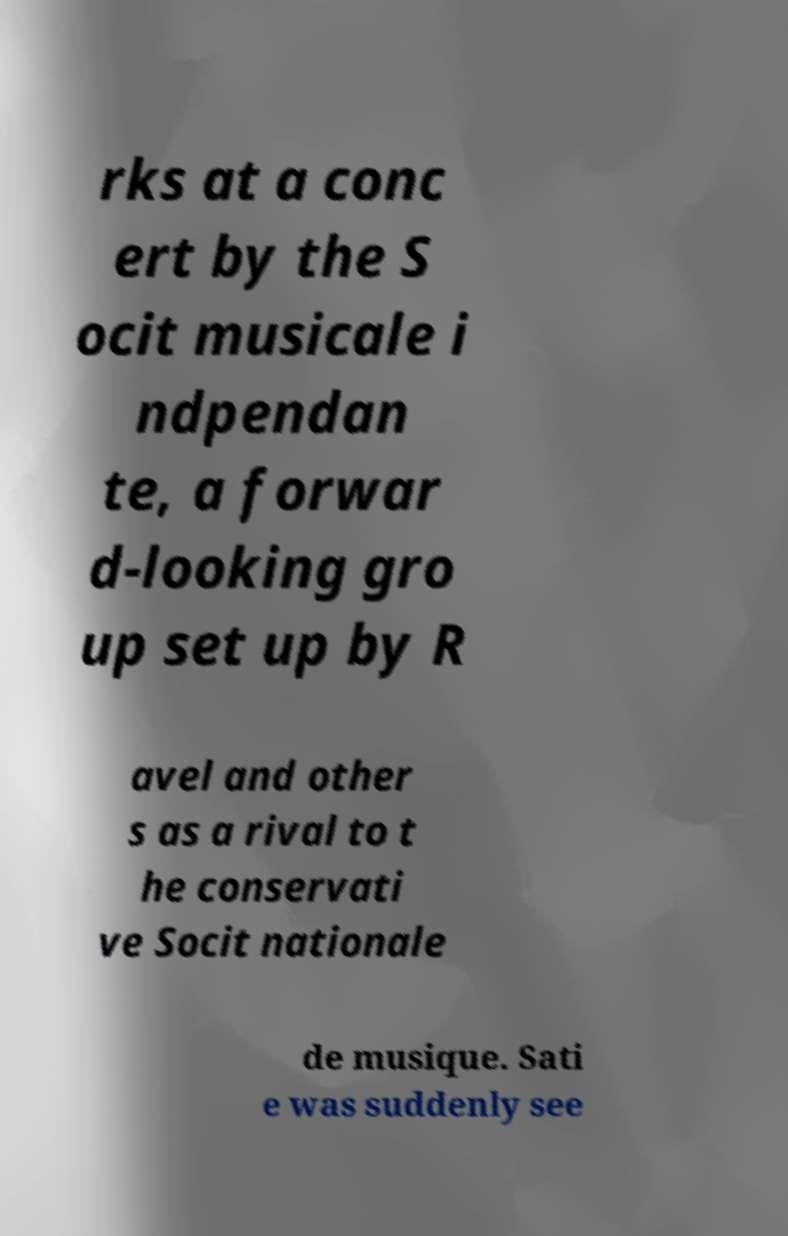Can you accurately transcribe the text from the provided image for me? rks at a conc ert by the S ocit musicale i ndpendan te, a forwar d-looking gro up set up by R avel and other s as a rival to t he conservati ve Socit nationale de musique. Sati e was suddenly see 